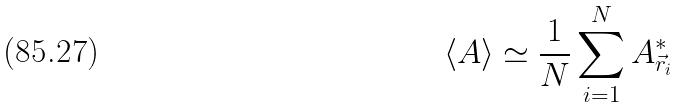<formula> <loc_0><loc_0><loc_500><loc_500>\langle A \rangle \simeq \frac { 1 } { N } \sum _ { i = 1 } ^ { N } A _ { \vec { r } _ { i } } ^ { * }</formula> 